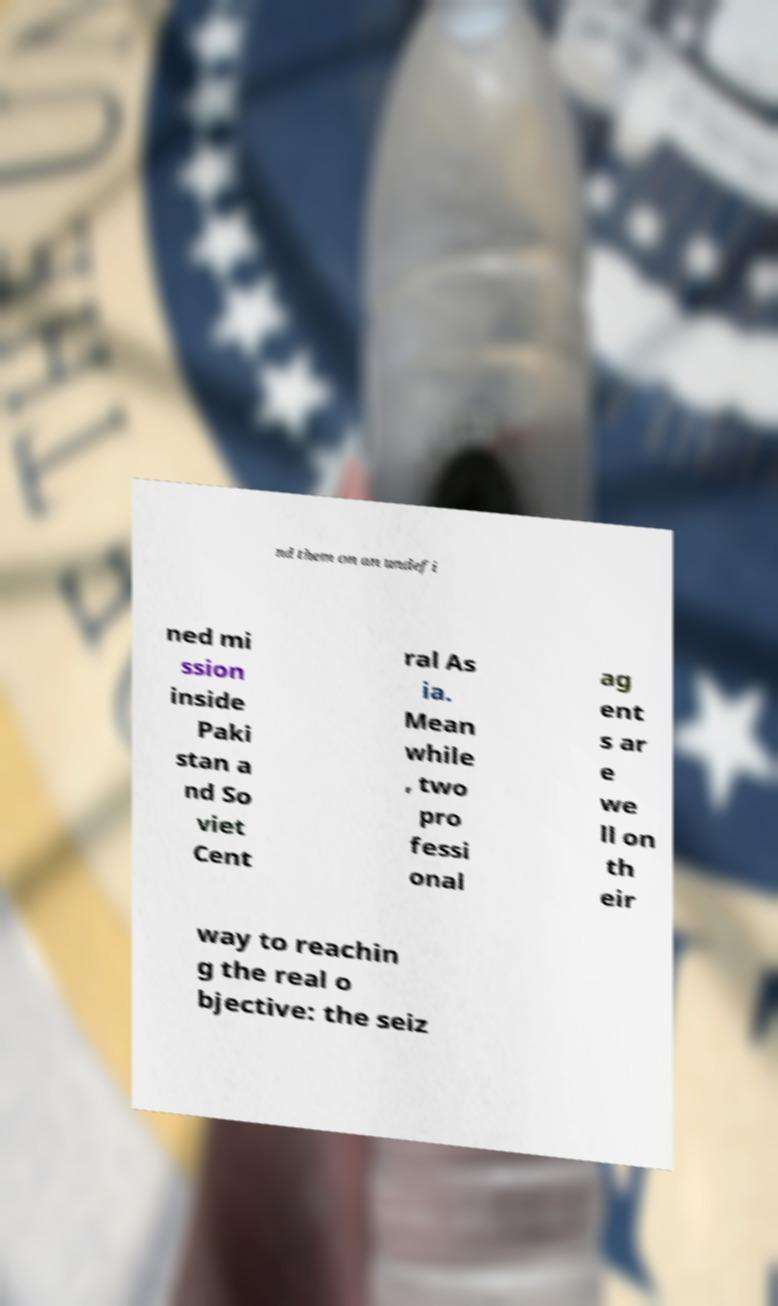Please identify and transcribe the text found in this image. nd them on an undefi ned mi ssion inside Paki stan a nd So viet Cent ral As ia. Mean while , two pro fessi onal ag ent s ar e we ll on th eir way to reachin g the real o bjective: the seiz 